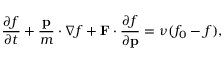<formula> <loc_0><loc_0><loc_500><loc_500>{ \frac { \partial f } { \partial t } } + { \frac { p } { m } } \cdot \nabla f + F \cdot { \frac { \partial f } { \partial p } } = \nu ( f _ { 0 } - f ) ,</formula> 